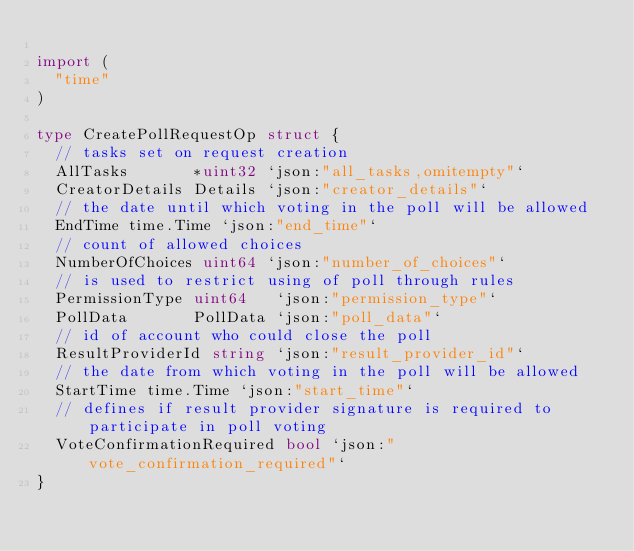Convert code to text. <code><loc_0><loc_0><loc_500><loc_500><_Go_>
import (
	"time"
)

type CreatePollRequestOp struct {
	// tasks set on request creation
	AllTasks       *uint32 `json:"all_tasks,omitempty"`
	CreatorDetails Details `json:"creator_details"`
	// the date until which voting in the poll will be allowed
	EndTime time.Time `json:"end_time"`
	// count of allowed choices
	NumberOfChoices uint64 `json:"number_of_choices"`
	// is used to restrict using of poll through rules
	PermissionType uint64   `json:"permission_type"`
	PollData       PollData `json:"poll_data"`
	// id of account who could close the poll
	ResultProviderId string `json:"result_provider_id"`
	// the date from which voting in the poll will be allowed
	StartTime time.Time `json:"start_time"`
	// defines if result provider signature is required to participate in poll voting
	VoteConfirmationRequired bool `json:"vote_confirmation_required"`
}
</code> 